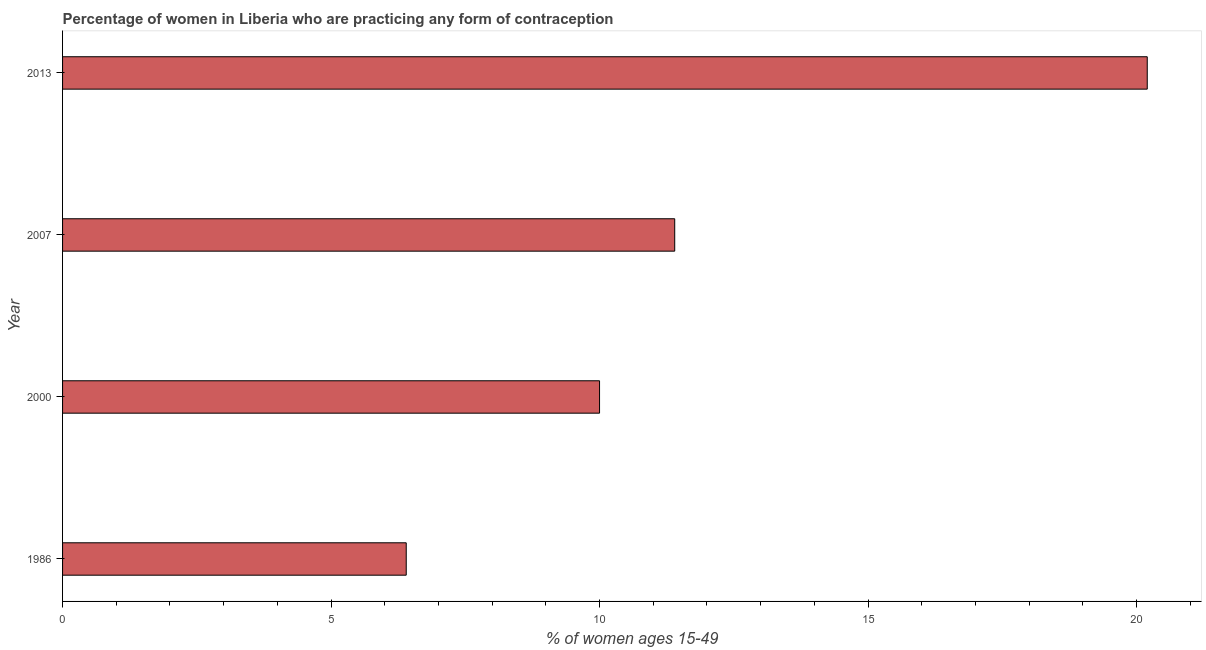Does the graph contain any zero values?
Provide a short and direct response. No. What is the title of the graph?
Provide a short and direct response. Percentage of women in Liberia who are practicing any form of contraception. What is the label or title of the X-axis?
Give a very brief answer. % of women ages 15-49. What is the label or title of the Y-axis?
Your answer should be very brief. Year. What is the contraceptive prevalence in 2000?
Make the answer very short. 10. Across all years, what is the maximum contraceptive prevalence?
Offer a terse response. 20.2. What is the difference between the contraceptive prevalence in 1986 and 2007?
Your answer should be compact. -5. In how many years, is the contraceptive prevalence greater than 7 %?
Give a very brief answer. 3. Do a majority of the years between 2000 and 2007 (inclusive) have contraceptive prevalence greater than 20 %?
Ensure brevity in your answer.  No. What is the ratio of the contraceptive prevalence in 2000 to that in 2007?
Make the answer very short. 0.88. Is the contraceptive prevalence in 2000 less than that in 2013?
Make the answer very short. Yes. Is the sum of the contraceptive prevalence in 1986 and 2013 greater than the maximum contraceptive prevalence across all years?
Provide a succinct answer. Yes. What is the difference between the highest and the lowest contraceptive prevalence?
Ensure brevity in your answer.  13.8. How many bars are there?
Give a very brief answer. 4. Are all the bars in the graph horizontal?
Provide a succinct answer. Yes. How many years are there in the graph?
Give a very brief answer. 4. What is the difference between two consecutive major ticks on the X-axis?
Provide a short and direct response. 5. What is the % of women ages 15-49 in 1986?
Provide a succinct answer. 6.4. What is the % of women ages 15-49 in 2000?
Your answer should be compact. 10. What is the % of women ages 15-49 of 2007?
Offer a very short reply. 11.4. What is the % of women ages 15-49 in 2013?
Your answer should be very brief. 20.2. What is the difference between the % of women ages 15-49 in 1986 and 2007?
Your answer should be very brief. -5. What is the difference between the % of women ages 15-49 in 1986 and 2013?
Give a very brief answer. -13.8. What is the difference between the % of women ages 15-49 in 2000 and 2013?
Make the answer very short. -10.2. What is the difference between the % of women ages 15-49 in 2007 and 2013?
Provide a succinct answer. -8.8. What is the ratio of the % of women ages 15-49 in 1986 to that in 2000?
Offer a very short reply. 0.64. What is the ratio of the % of women ages 15-49 in 1986 to that in 2007?
Provide a succinct answer. 0.56. What is the ratio of the % of women ages 15-49 in 1986 to that in 2013?
Provide a succinct answer. 0.32. What is the ratio of the % of women ages 15-49 in 2000 to that in 2007?
Your response must be concise. 0.88. What is the ratio of the % of women ages 15-49 in 2000 to that in 2013?
Provide a short and direct response. 0.49. What is the ratio of the % of women ages 15-49 in 2007 to that in 2013?
Keep it short and to the point. 0.56. 